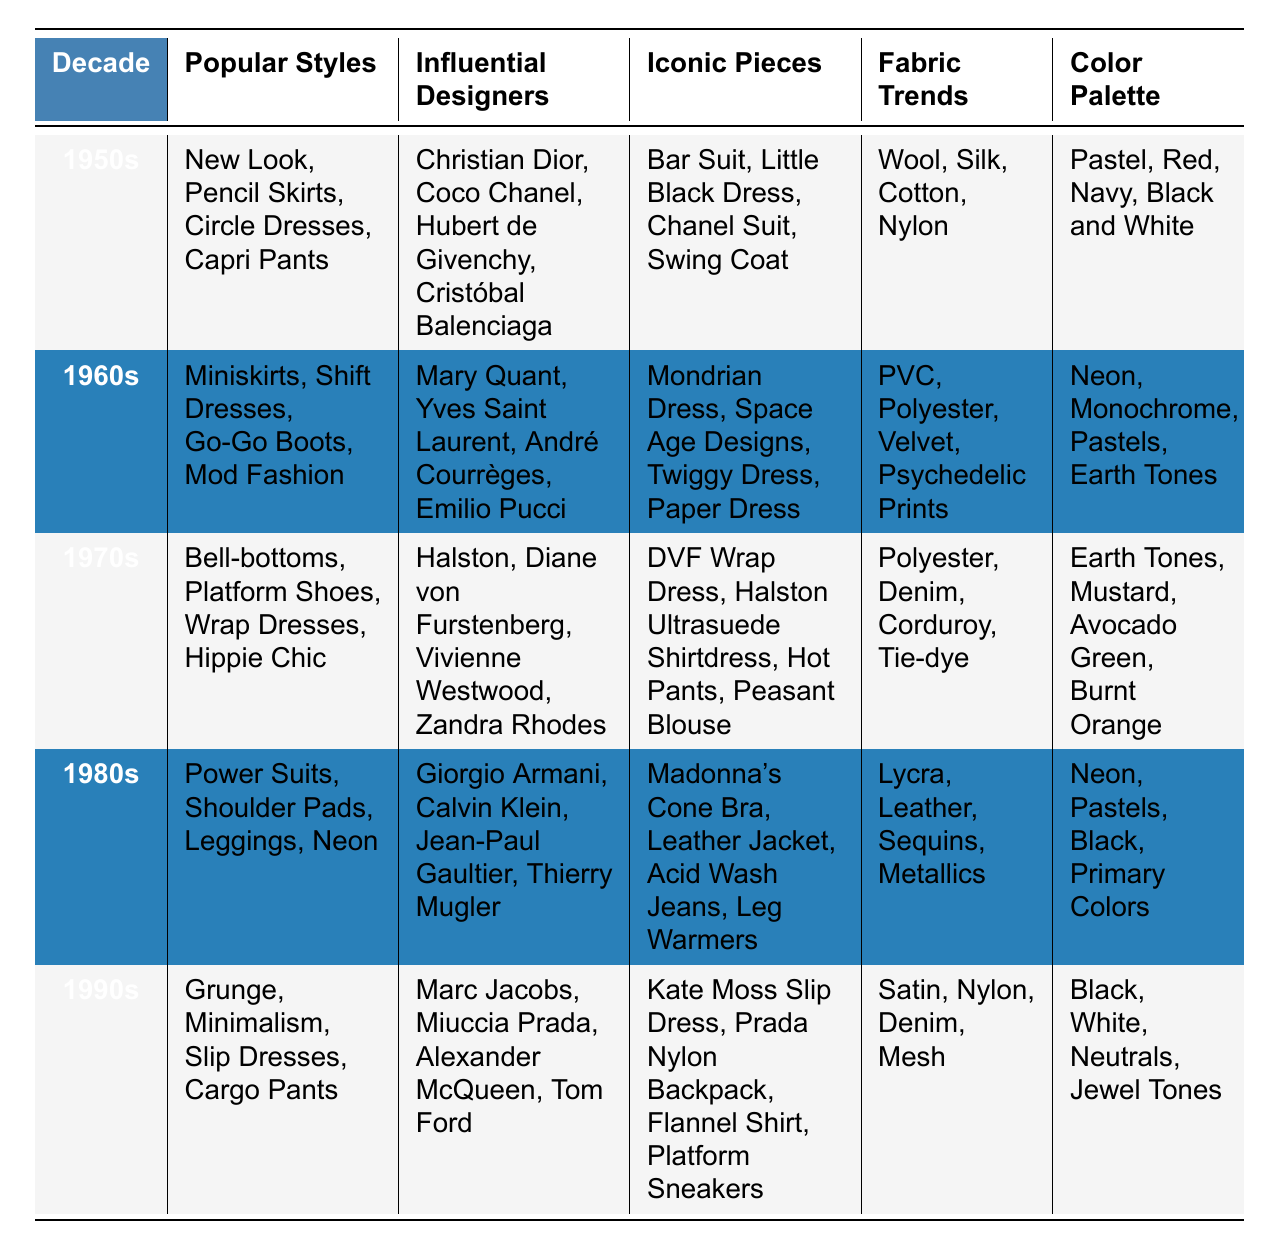What were the popular styles in the 1980s? According to the table, the popular styles listed for the 1980s include Power Suits, Shoulder Pads, Leggings, and Neon.
Answer: Power Suits, Shoulder Pads, Leggings, Neon Who were the influential designers of the 1960s? The table states that the influential designers in the 1960s were Mary Quant, Yves Saint Laurent, André Courrèges, and Emilio Pucci.
Answer: Mary Quant, Yves Saint Laurent, André Courrèges, Emilio Pucci Did the 1970s showcase any notable fabric trends? Yes, the table indicating the fabric trends of the 1970s includes Polyester, Denim, Corduroy, and Tie-dye.
Answer: Yes Which decade featured the color palette of Pastels and Earth Tones? The table shows that Pastels were part of the 1960s palette, while Earth Tones were part of the 1970s palette. Both colors occur in different decades, but Earth Tones belong to the 1970s.
Answer: 1970s How many iconic pieces are mentioned for the 1990s? For the 1990s, the table lists four iconic pieces: Kate Moss Slip Dress, Prada Nylon Backpack, Flannel Shirt, and Platform Sneakers. Hence, the count is four.
Answer: Four Which decade had the most influential designers according to the table? Looking at the table, all decades mentioned four influential designers each, so no decade is more abundant than the others in this respect.
Answer: Equal number (four each) Is the DVF Wrap Dress associated with the 1960s or the 1970s? The table indicates that the DVF Wrap Dress is associated with the 1970s; hence, it is not related to the 1960s.
Answer: 1970s List the fabric trends for the 1950s and 1980s. The table shows the fabric trends for the 1950s are Wool, Silk, Cotton, and Nylon, while for the 1980s, they are Lycra, Leather, Sequins, and Metallics.
Answer: 1950s: Wool, Silk, Cotton, Nylon; 1980s: Lycra, Leather, Sequins, Metallics What is the difference in the color palette between the 1960s and the 1990s? The color palette for the 1960s includes Neon, Monochrome, Pastels, and Earth Tones, while for the 1990s, it includes Black, White, Neutrals, and Jewel Tones. The difference in colors is that the 1960s have brighter and more varied shades, whereas the 1990s lean towards neutral and darker tones.
Answer: 1960s: Bright colors; 1990s: Neutral colors Which iconic piece from the 1980s was famously worn by Madonna? According to the table, the iconic piece from the 1980s famously worn by Madonna is her Cone Bra.
Answer: Cone Bra 